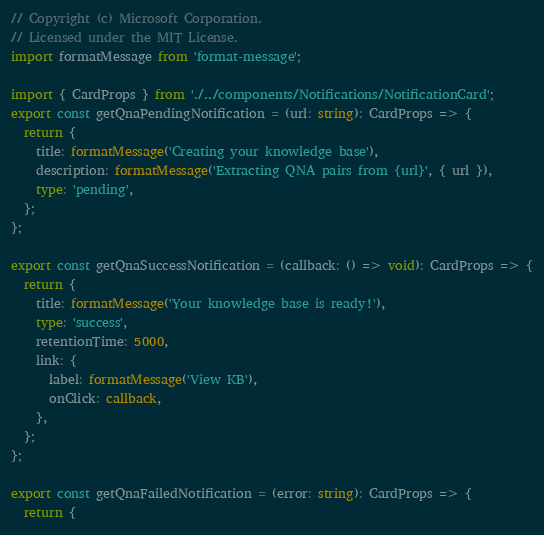<code> <loc_0><loc_0><loc_500><loc_500><_TypeScript_>// Copyright (c) Microsoft Corporation.
// Licensed under the MIT License.
import formatMessage from 'format-message';

import { CardProps } from './../components/Notifications/NotificationCard';
export const getQnaPendingNotification = (url: string): CardProps => {
  return {
    title: formatMessage('Creating your knowledge base'),
    description: formatMessage('Extracting QNA pairs from {url}', { url }),
    type: 'pending',
  };
};

export const getQnaSuccessNotification = (callback: () => void): CardProps => {
  return {
    title: formatMessage('Your knowledge base is ready!'),
    type: 'success',
    retentionTime: 5000,
    link: {
      label: formatMessage('View KB'),
      onClick: callback,
    },
  };
};

export const getQnaFailedNotification = (error: string): CardProps => {
  return {</code> 